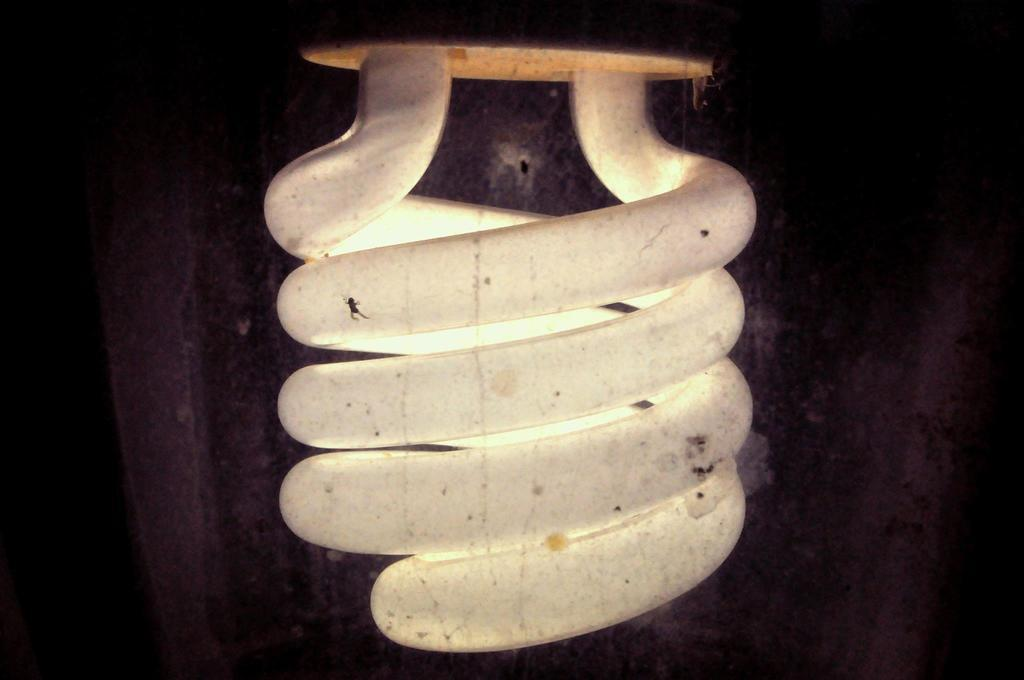What is the main subject of the image? The main subject of the image is a light bulb. Where is the light bulb located in the image? The light bulb is in the center of the image. What can be observed about the background of the image? The background of the image is dark. What role does the actor play in the image? There is no actor present in the image; it features a light bulb in the center of a dark background. What is the judge's opinion on the afterthought in the image? There is no judge or afterthought present in the image; it only features a light bulb in the center of a dark background. 